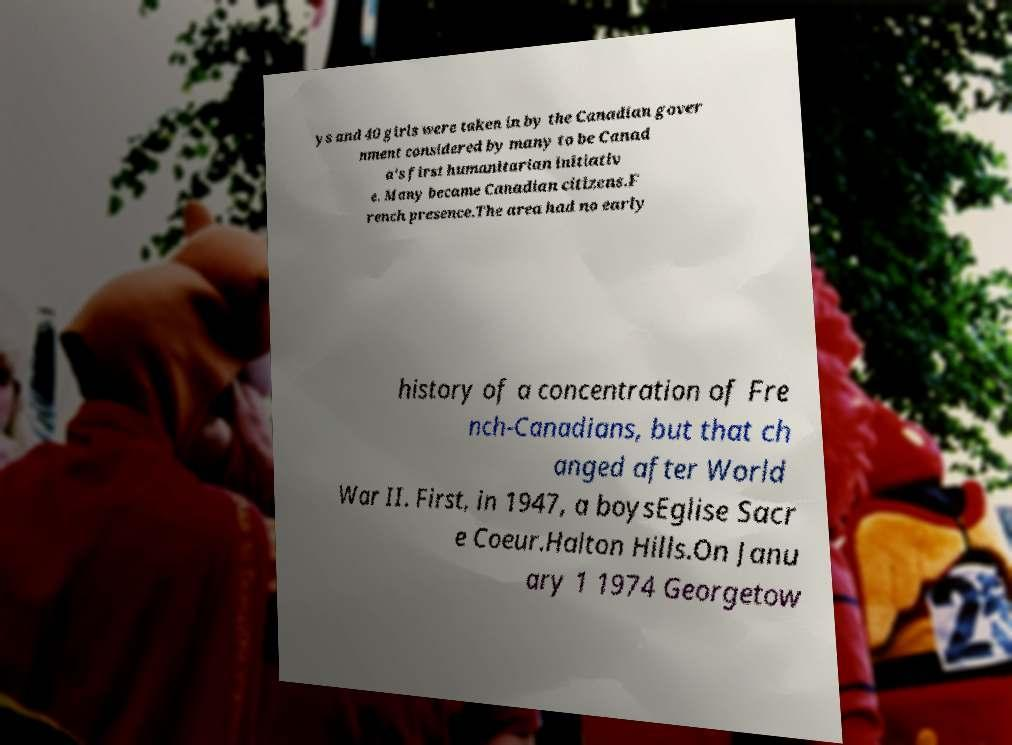Can you accurately transcribe the text from the provided image for me? ys and 40 girls were taken in by the Canadian gover nment considered by many to be Canad a's first humanitarian initiativ e. Many became Canadian citizens.F rench presence.The area had no early history of a concentration of Fre nch-Canadians, but that ch anged after World War II. First, in 1947, a boysEglise Sacr e Coeur.Halton Hills.On Janu ary 1 1974 Georgetow 